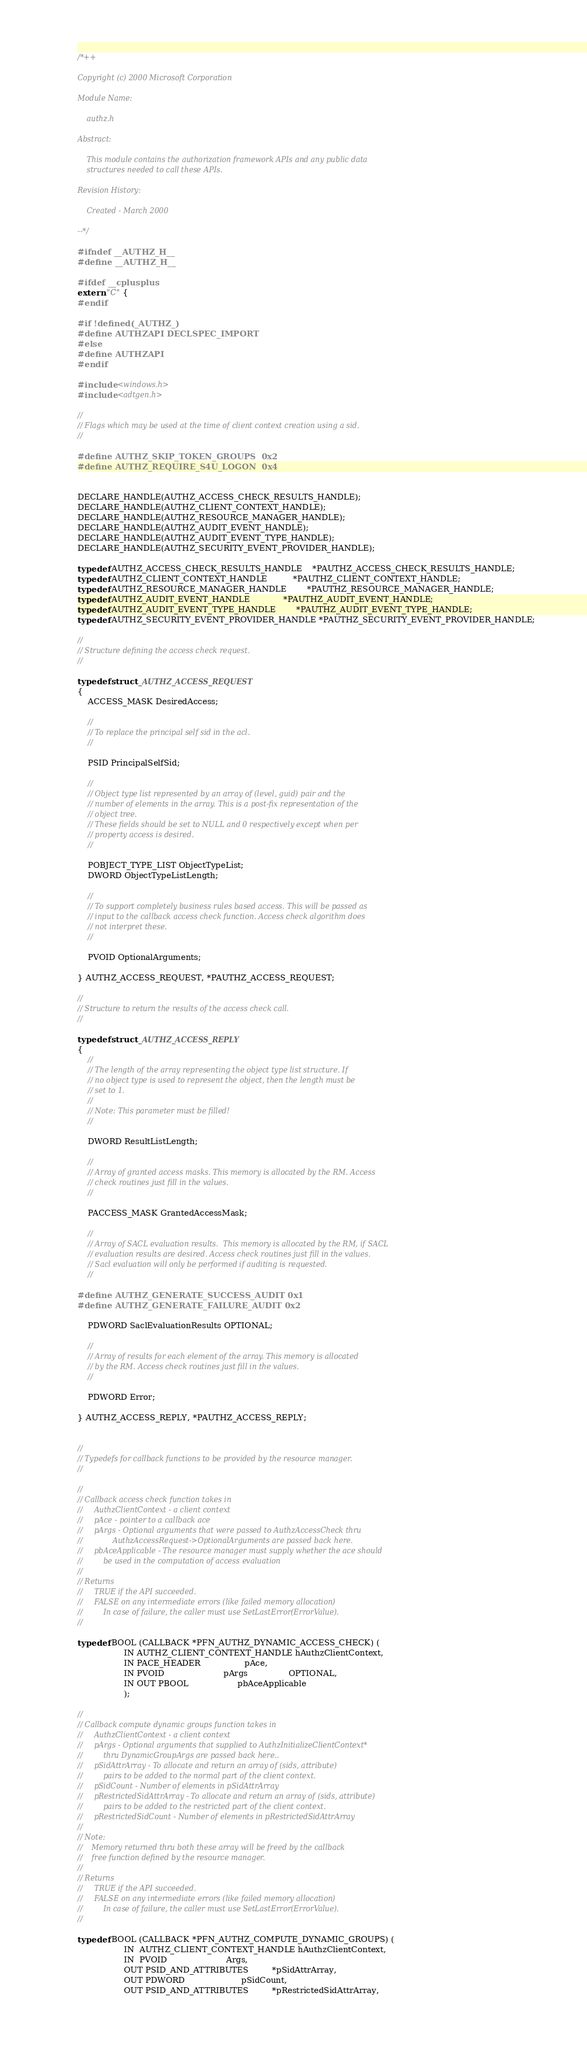Convert code to text. <code><loc_0><loc_0><loc_500><loc_500><_C_>/*++

Copyright (c) 2000 Microsoft Corporation

Module Name:

    authz.h

Abstract:

    This module contains the authorization framework APIs and any public data
    structures needed to call these APIs.

Revision History:

    Created - March 2000

--*/

#ifndef __AUTHZ_H__
#define __AUTHZ_H__

#ifdef __cplusplus
extern "C" {
#endif

#if !defined(_AUTHZ_)
#define AUTHZAPI DECLSPEC_IMPORT
#else 
#define AUTHZAPI
#endif

#include <windows.h>
#include <adtgen.h>

//
// Flags which may be used at the time of client context creation using a sid.
//

#define AUTHZ_SKIP_TOKEN_GROUPS  0x2
#define AUTHZ_REQUIRE_S4U_LOGON  0x4

              
DECLARE_HANDLE(AUTHZ_ACCESS_CHECK_RESULTS_HANDLE);
DECLARE_HANDLE(AUTHZ_CLIENT_CONTEXT_HANDLE);
DECLARE_HANDLE(AUTHZ_RESOURCE_MANAGER_HANDLE);
DECLARE_HANDLE(AUTHZ_AUDIT_EVENT_HANDLE);
DECLARE_HANDLE(AUTHZ_AUDIT_EVENT_TYPE_HANDLE);
DECLARE_HANDLE(AUTHZ_SECURITY_EVENT_PROVIDER_HANDLE);

typedef AUTHZ_ACCESS_CHECK_RESULTS_HANDLE    *PAUTHZ_ACCESS_CHECK_RESULTS_HANDLE;
typedef AUTHZ_CLIENT_CONTEXT_HANDLE          *PAUTHZ_CLIENT_CONTEXT_HANDLE;
typedef AUTHZ_RESOURCE_MANAGER_HANDLE        *PAUTHZ_RESOURCE_MANAGER_HANDLE;
typedef AUTHZ_AUDIT_EVENT_HANDLE             *PAUTHZ_AUDIT_EVENT_HANDLE;
typedef AUTHZ_AUDIT_EVENT_TYPE_HANDLE        *PAUTHZ_AUDIT_EVENT_TYPE_HANDLE;
typedef AUTHZ_SECURITY_EVENT_PROVIDER_HANDLE *PAUTHZ_SECURITY_EVENT_PROVIDER_HANDLE;

//
// Structure defining the access check request.
//

typedef struct _AUTHZ_ACCESS_REQUEST
{
    ACCESS_MASK DesiredAccess;

    //
    // To replace the principal self sid in the acl.
    //

    PSID PrincipalSelfSid;

    //
    // Object type list represented by an array of (level, guid) pair and the
    // number of elements in the array. This is a post-fix representation of the
    // object tree.
    // These fields should be set to NULL and 0 respectively except when per
    // property access is desired.
    //

    POBJECT_TYPE_LIST ObjectTypeList;
    DWORD ObjectTypeListLength;

    //
    // To support completely business rules based access. This will be passed as
    // input to the callback access check function. Access check algorithm does
    // not interpret these.
    //

    PVOID OptionalArguments;
    
} AUTHZ_ACCESS_REQUEST, *PAUTHZ_ACCESS_REQUEST;

//
// Structure to return the results of the access check call.
//

typedef struct _AUTHZ_ACCESS_REPLY
{
    //
    // The length of the array representing the object type list structure. If
    // no object type is used to represent the object, then the length must be
    // set to 1.
    //
    // Note: This parameter must be filled!
    //

    DWORD ResultListLength;

    //
    // Array of granted access masks. This memory is allocated by the RM. Access
    // check routines just fill in the values.
    //

    PACCESS_MASK GrantedAccessMask;
    
    //
    // Array of SACL evaluation results.  This memory is allocated by the RM, if SACL
    // evaluation results are desired. Access check routines just fill in the values.
    // Sacl evaluation will only be performed if auditing is requested.
    //
    
#define AUTHZ_GENERATE_SUCCESS_AUDIT 0x1
#define AUTHZ_GENERATE_FAILURE_AUDIT 0x2

    PDWORD SaclEvaluationResults OPTIONAL;
    
    //
    // Array of results for each element of the array. This memory is allocated
    // by the RM. Access check routines just fill in the values.
    //

    PDWORD Error;

} AUTHZ_ACCESS_REPLY, *PAUTHZ_ACCESS_REPLY;


//
// Typedefs for callback functions to be provided by the resource manager.
//

//
// Callback access check function takes in
//     AuthzClientContext - a client context
//     pAce - pointer to a callback ace
//     pArgs - Optional arguments that were passed to AuthzAccessCheck thru
//             AuthzAccessRequest->OptionalArguments are passed back here.
//     pbAceApplicable - The resource manager must supply whether the ace should
//         be used in the computation of access evaluation
//
// Returns
//     TRUE if the API succeeded.
//     FALSE on any intermediate errors (like failed memory allocation)
//         In case of failure, the caller must use SetLastError(ErrorValue).
//

typedef BOOL (CALLBACK *PFN_AUTHZ_DYNAMIC_ACCESS_CHECK) (
                  IN AUTHZ_CLIENT_CONTEXT_HANDLE hAuthzClientContext,
                  IN PACE_HEADER                 pAce,
                  IN PVOID                       pArgs                OPTIONAL,
                  IN OUT PBOOL                   pbAceApplicable
                  );

//
// Callback compute dynamic groups function takes in
//     AuthzClientContext - a client context
//     pArgs - Optional arguments that supplied to AuthzInitializeClientContext*
//         thru DynamicGroupArgs are passed back here..
//     pSidAttrArray - To allocate and return an array of (sids, attribute)
//         pairs to be added to the normal part of the client context.
//     pSidCount - Number of elements in pSidAttrArray
//     pRestrictedSidAttrArray - To allocate and return an array of (sids, attribute)
//         pairs to be added to the restricted part of the client context.
//     pRestrictedSidCount - Number of elements in pRestrictedSidAttrArray
//
// Note:
//    Memory returned thru both these array will be freed by the callback
//    free function defined by the resource manager.
//
// Returns
//     TRUE if the API succeeded.
//     FALSE on any intermediate errors (like failed memory allocation)
//         In case of failure, the caller must use SetLastError(ErrorValue).
//

typedef BOOL (CALLBACK *PFN_AUTHZ_COMPUTE_DYNAMIC_GROUPS) (
                  IN  AUTHZ_CLIENT_CONTEXT_HANDLE hAuthzClientContext,
                  IN  PVOID                       Args,
                  OUT PSID_AND_ATTRIBUTES         *pSidAttrArray,
                  OUT PDWORD                      pSidCount,
                  OUT PSID_AND_ATTRIBUTES         *pRestrictedSidAttrArray,</code> 